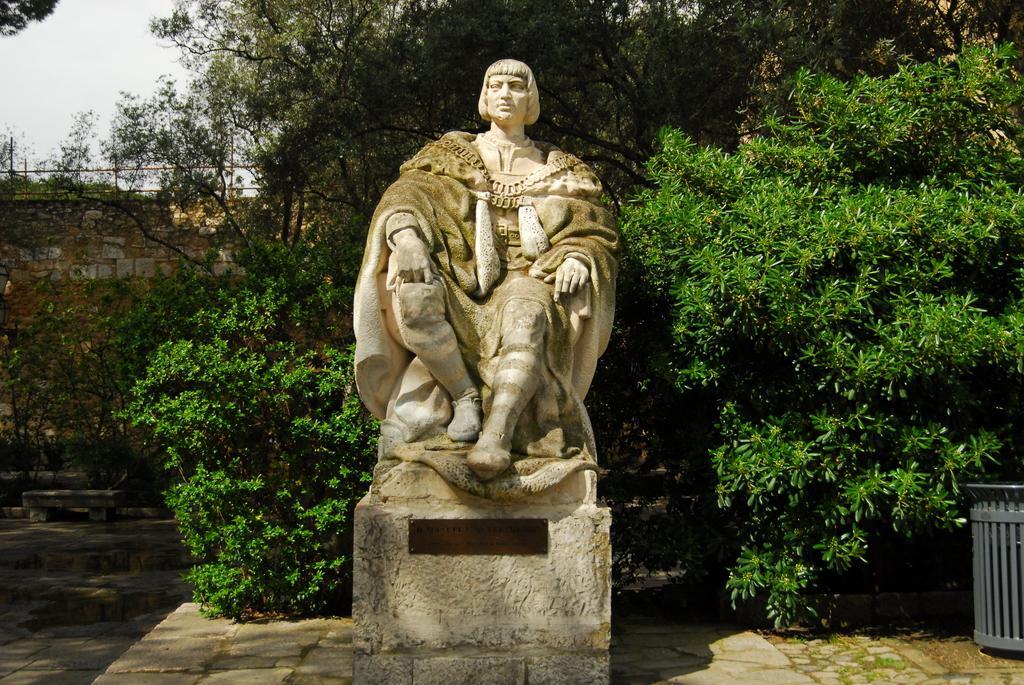Could you give a brief overview of what you see in this image? In this image we can see a statue, we can see dustbin, trees, stonewall and the sky in the background. 